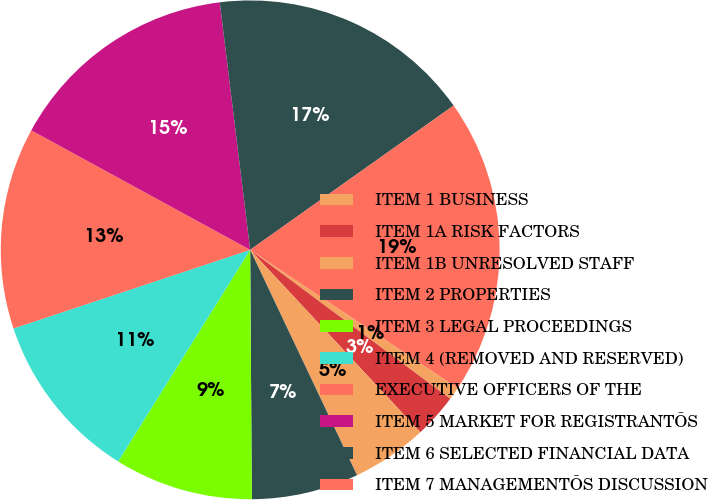<chart> <loc_0><loc_0><loc_500><loc_500><pie_chart><fcel>ITEM 1 BUSINESS<fcel>ITEM 1A RISK FACTORS<fcel>ITEM 1B UNRESOLVED STAFF<fcel>ITEM 2 PROPERTIES<fcel>ITEM 3 LEGAL PROCEEDINGS<fcel>ITEM 4 (REMOVED AND RESERVED)<fcel>EXECUTIVE OFFICERS OF THE<fcel>ITEM 5 MARKET FOR REGISTRANTÕS<fcel>ITEM 6 SELECTED FINANCIAL DATA<fcel>ITEM 7 MANAGEMENTÕS DISCUSSION<nl><fcel>0.83%<fcel>2.87%<fcel>4.9%<fcel>6.94%<fcel>8.98%<fcel>11.02%<fcel>13.06%<fcel>15.1%<fcel>17.13%<fcel>19.17%<nl></chart> 